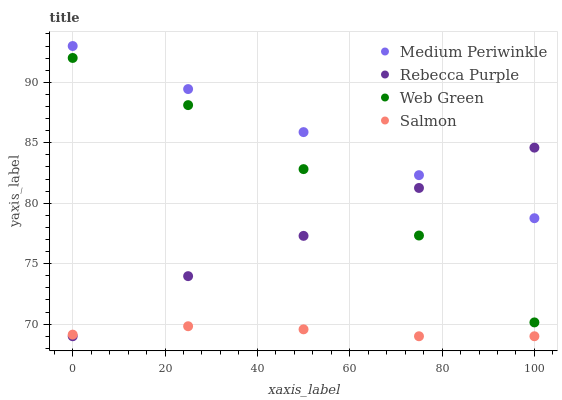Does Salmon have the minimum area under the curve?
Answer yes or no. Yes. Does Medium Periwinkle have the maximum area under the curve?
Answer yes or no. Yes. Does Rebecca Purple have the minimum area under the curve?
Answer yes or no. No. Does Rebecca Purple have the maximum area under the curve?
Answer yes or no. No. Is Medium Periwinkle the smoothest?
Answer yes or no. Yes. Is Web Green the roughest?
Answer yes or no. Yes. Is Rebecca Purple the smoothest?
Answer yes or no. No. Is Rebecca Purple the roughest?
Answer yes or no. No. Does Salmon have the lowest value?
Answer yes or no. Yes. Does Medium Periwinkle have the lowest value?
Answer yes or no. No. Does Medium Periwinkle have the highest value?
Answer yes or no. Yes. Does Rebecca Purple have the highest value?
Answer yes or no. No. Is Web Green less than Medium Periwinkle?
Answer yes or no. Yes. Is Medium Periwinkle greater than Salmon?
Answer yes or no. Yes. Does Web Green intersect Rebecca Purple?
Answer yes or no. Yes. Is Web Green less than Rebecca Purple?
Answer yes or no. No. Is Web Green greater than Rebecca Purple?
Answer yes or no. No. Does Web Green intersect Medium Periwinkle?
Answer yes or no. No. 